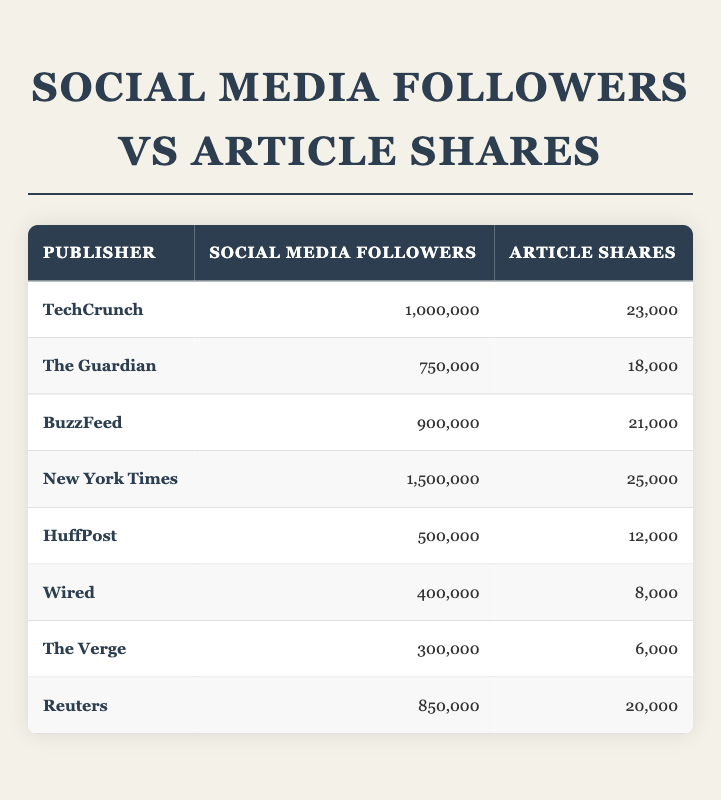What is the publisher with the highest number of social media followers? By examining the "Social Media Followers" column, we can see that the "New York Times" has the highest value at 1,500,000 followers.
Answer: New York Times What is the total number of article shares for all publishers combined? To find the total, we sum all the article shares: 23,000 + 18,000 + 21,000 + 25,000 + 12,000 + 8,000 + 6,000 + 20,000 = 133,000.
Answer: 133,000 Does HuffPost have more article shares than Wired? Comparing the article shares of HuffPost (12,000) and Wired (8,000), we see that HuffPost has more shares.
Answer: Yes What is the average number of social media followers among all publishers? There are 8 publishers. To find the average, we sum the followers: 1,000,000 + 750,000 + 900,000 + 1,500,000 + 500,000 + 400,000 + 300,000 + 850,000 = 5,150,000, and then divide by 8: 5,150,000 / 8 = 643,750.
Answer: 643,750 Which publisher has the lowest number of article shares? Looking through the "Article Shares" column, we see that "The Verge" has the lowest share count at 6,000.
Answer: The Verge Is the correlation between social media followers and article shares positive? A quick glance at the data shows that as the number of followers increases, article shares generally increase as well, indicating a positive correlation.
Answer: Yes What is the difference in article shares between the highest and lowest publishers? The publisher with the highest shares is "New York Times" with 25,000 shares and the lowest is "The Verge" with 6,000 shares. The difference is 25,000 - 6,000 = 19,000.
Answer: 19,000 Which publisher has the largest gap between social media followers and article shares? To find the largest gap, we calculate the difference for each publisher: TechCrunch (1,000,000 - 23,000 = 977,000), The Guardian (750,000 - 18,000 = 732,000), BuzzFeed (900,000 - 21,000 = 879,000), New York Times (1,500,000 - 25,000 = 1,475,000), HuffPost (500,000 - 12,000 = 488,000), Wired (400,000 - 8,000 = 392,000), The Verge (300,000 - 6,000 = 294,000), Reuters (850,000 - 20,000 = 830,000). The largest gap is New York Times with 1,475,000.
Answer: New York Times 